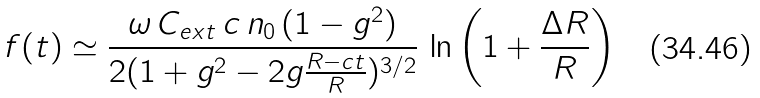Convert formula to latex. <formula><loc_0><loc_0><loc_500><loc_500>f ( t ) \simeq \frac { \omega \, C _ { e x t } \, c \, n _ { 0 } \, ( 1 - g ^ { 2 } ) } { 2 ( 1 + g ^ { 2 } - 2 g \frac { R - c t } { R } ) ^ { 3 / 2 } } \, \ln \left ( 1 + \frac { \Delta R } { R } \right )</formula> 